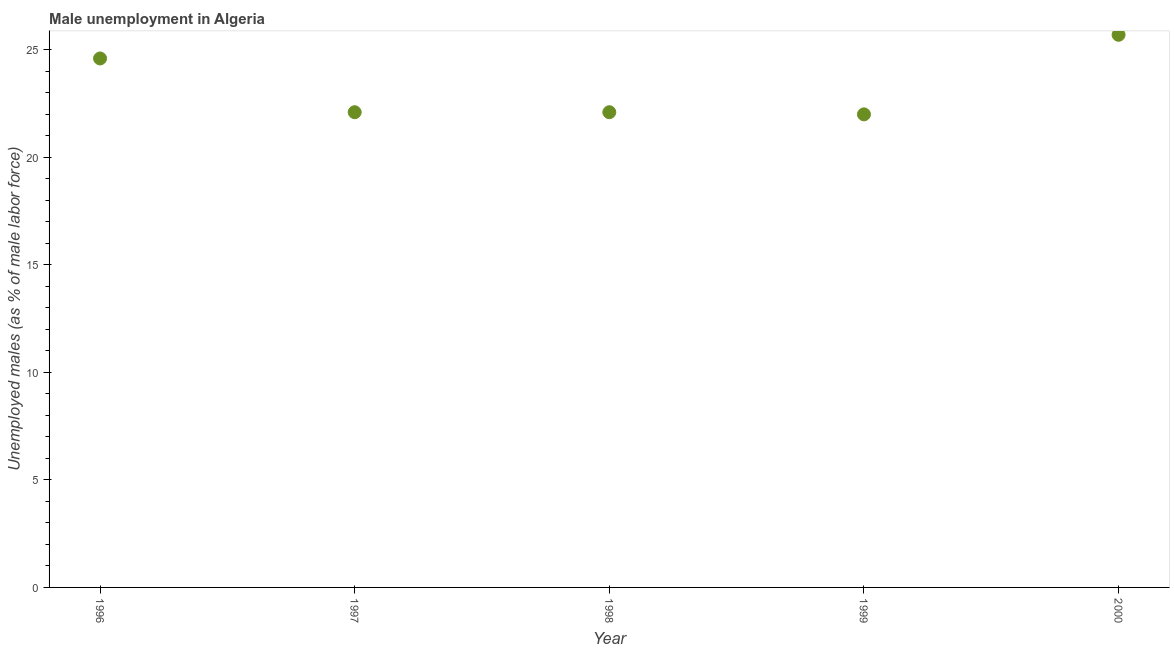What is the unemployed males population in 1998?
Your answer should be compact. 22.1. Across all years, what is the maximum unemployed males population?
Provide a succinct answer. 25.7. In which year was the unemployed males population maximum?
Make the answer very short. 2000. What is the sum of the unemployed males population?
Give a very brief answer. 116.5. What is the difference between the unemployed males population in 1998 and 1999?
Provide a succinct answer. 0.1. What is the average unemployed males population per year?
Give a very brief answer. 23.3. What is the median unemployed males population?
Make the answer very short. 22.1. In how many years, is the unemployed males population greater than 12 %?
Make the answer very short. 5. Do a majority of the years between 1999 and 1998 (inclusive) have unemployed males population greater than 8 %?
Provide a short and direct response. No. What is the ratio of the unemployed males population in 1996 to that in 2000?
Your answer should be compact. 0.96. What is the difference between the highest and the second highest unemployed males population?
Your answer should be very brief. 1.1. Is the sum of the unemployed males population in 1997 and 1998 greater than the maximum unemployed males population across all years?
Provide a succinct answer. Yes. What is the difference between the highest and the lowest unemployed males population?
Offer a terse response. 3.7. In how many years, is the unemployed males population greater than the average unemployed males population taken over all years?
Your response must be concise. 2. How many dotlines are there?
Your answer should be very brief. 1. How many years are there in the graph?
Provide a short and direct response. 5. What is the difference between two consecutive major ticks on the Y-axis?
Your response must be concise. 5. Does the graph contain grids?
Provide a succinct answer. No. What is the title of the graph?
Provide a succinct answer. Male unemployment in Algeria. What is the label or title of the X-axis?
Give a very brief answer. Year. What is the label or title of the Y-axis?
Your answer should be compact. Unemployed males (as % of male labor force). What is the Unemployed males (as % of male labor force) in 1996?
Make the answer very short. 24.6. What is the Unemployed males (as % of male labor force) in 1997?
Provide a succinct answer. 22.1. What is the Unemployed males (as % of male labor force) in 1998?
Make the answer very short. 22.1. What is the Unemployed males (as % of male labor force) in 2000?
Ensure brevity in your answer.  25.7. What is the difference between the Unemployed males (as % of male labor force) in 1996 and 1997?
Give a very brief answer. 2.5. What is the difference between the Unemployed males (as % of male labor force) in 1996 and 1998?
Make the answer very short. 2.5. What is the difference between the Unemployed males (as % of male labor force) in 1997 and 1998?
Your answer should be very brief. 0. What is the ratio of the Unemployed males (as % of male labor force) in 1996 to that in 1997?
Your response must be concise. 1.11. What is the ratio of the Unemployed males (as % of male labor force) in 1996 to that in 1998?
Keep it short and to the point. 1.11. What is the ratio of the Unemployed males (as % of male labor force) in 1996 to that in 1999?
Provide a short and direct response. 1.12. What is the ratio of the Unemployed males (as % of male labor force) in 1996 to that in 2000?
Offer a very short reply. 0.96. What is the ratio of the Unemployed males (as % of male labor force) in 1997 to that in 1999?
Your answer should be compact. 1. What is the ratio of the Unemployed males (as % of male labor force) in 1997 to that in 2000?
Provide a succinct answer. 0.86. What is the ratio of the Unemployed males (as % of male labor force) in 1998 to that in 1999?
Offer a very short reply. 1. What is the ratio of the Unemployed males (as % of male labor force) in 1998 to that in 2000?
Offer a terse response. 0.86. What is the ratio of the Unemployed males (as % of male labor force) in 1999 to that in 2000?
Your answer should be very brief. 0.86. 